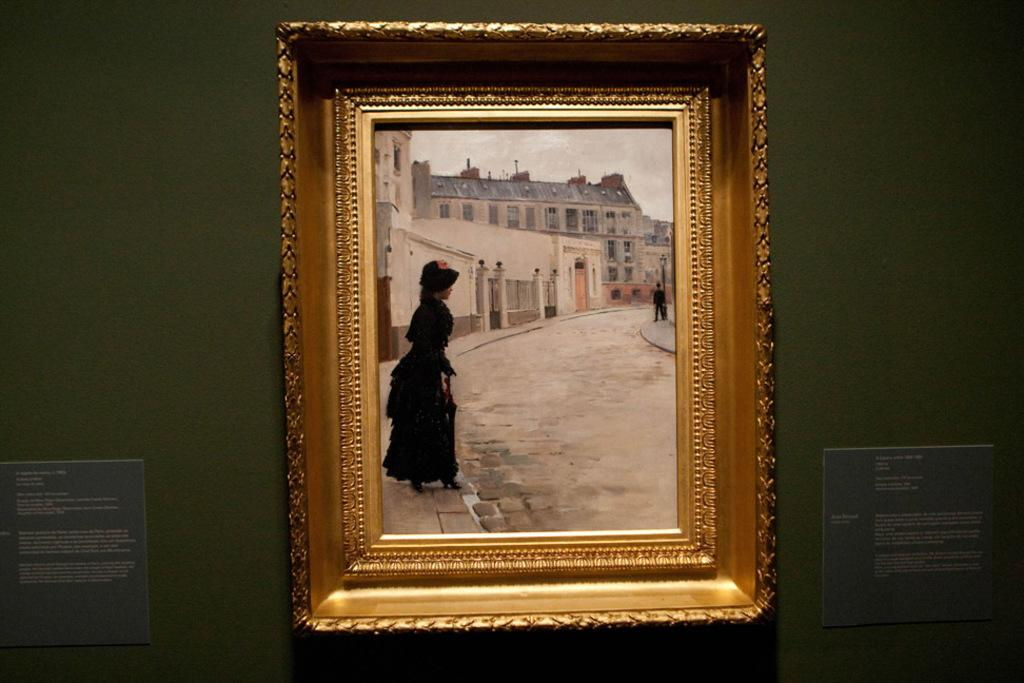What is the main object in the image? There is a frame in the image. What is on the wall near the frame? There are boards on the wall in the image. What can be seen inside the frame? The frame contains images of people, buildings, and poles. What is visible at the bottom of the image? There is a road at the bottom of the image. How many pets can be seen in the image? There are no pets visible in the image. Is there a window in the image? There is no window present in the image. 